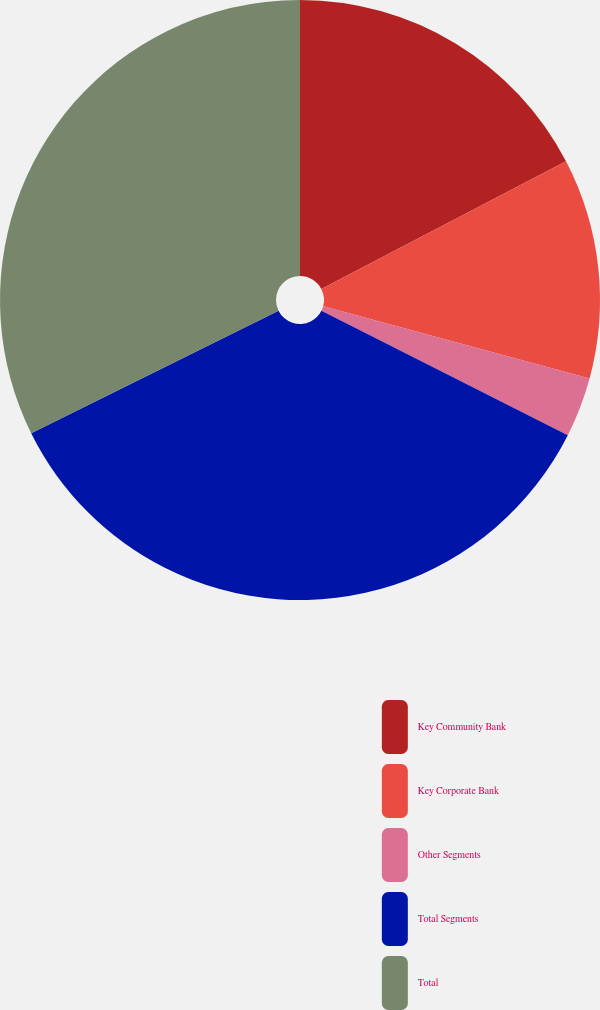Convert chart. <chart><loc_0><loc_0><loc_500><loc_500><pie_chart><fcel>Key Community Bank<fcel>Key Corporate Bank<fcel>Other Segments<fcel>Total Segments<fcel>Total<nl><fcel>17.35%<fcel>11.86%<fcel>3.23%<fcel>35.24%<fcel>32.32%<nl></chart> 